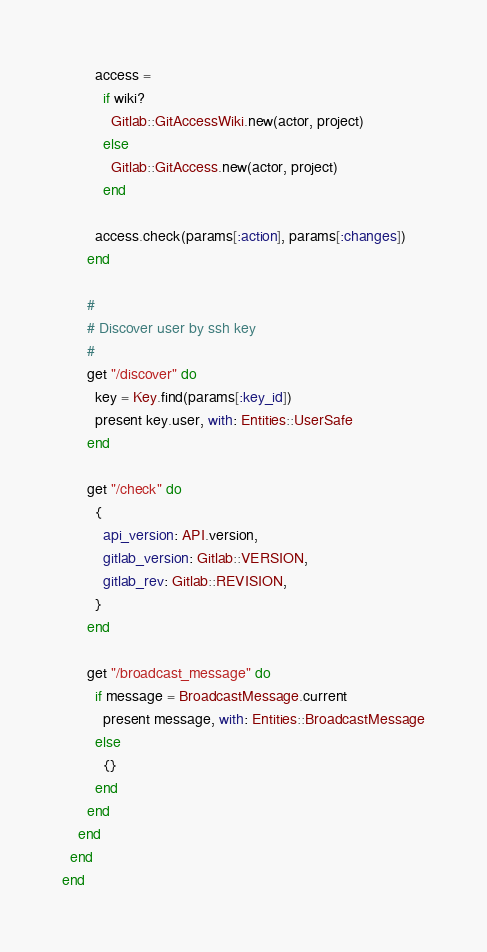Convert code to text. <code><loc_0><loc_0><loc_500><loc_500><_Ruby_>        access =
          if wiki?
            Gitlab::GitAccessWiki.new(actor, project)
          else
            Gitlab::GitAccess.new(actor, project)
          end

        access.check(params[:action], params[:changes])
      end

      #
      # Discover user by ssh key
      #
      get "/discover" do
        key = Key.find(params[:key_id])
        present key.user, with: Entities::UserSafe
      end

      get "/check" do
        {
          api_version: API.version,
          gitlab_version: Gitlab::VERSION,
          gitlab_rev: Gitlab::REVISION,
        }
      end

      get "/broadcast_message" do
        if message = BroadcastMessage.current
          present message, with: Entities::BroadcastMessage
        else
          {}
        end
      end
    end
  end
end
</code> 